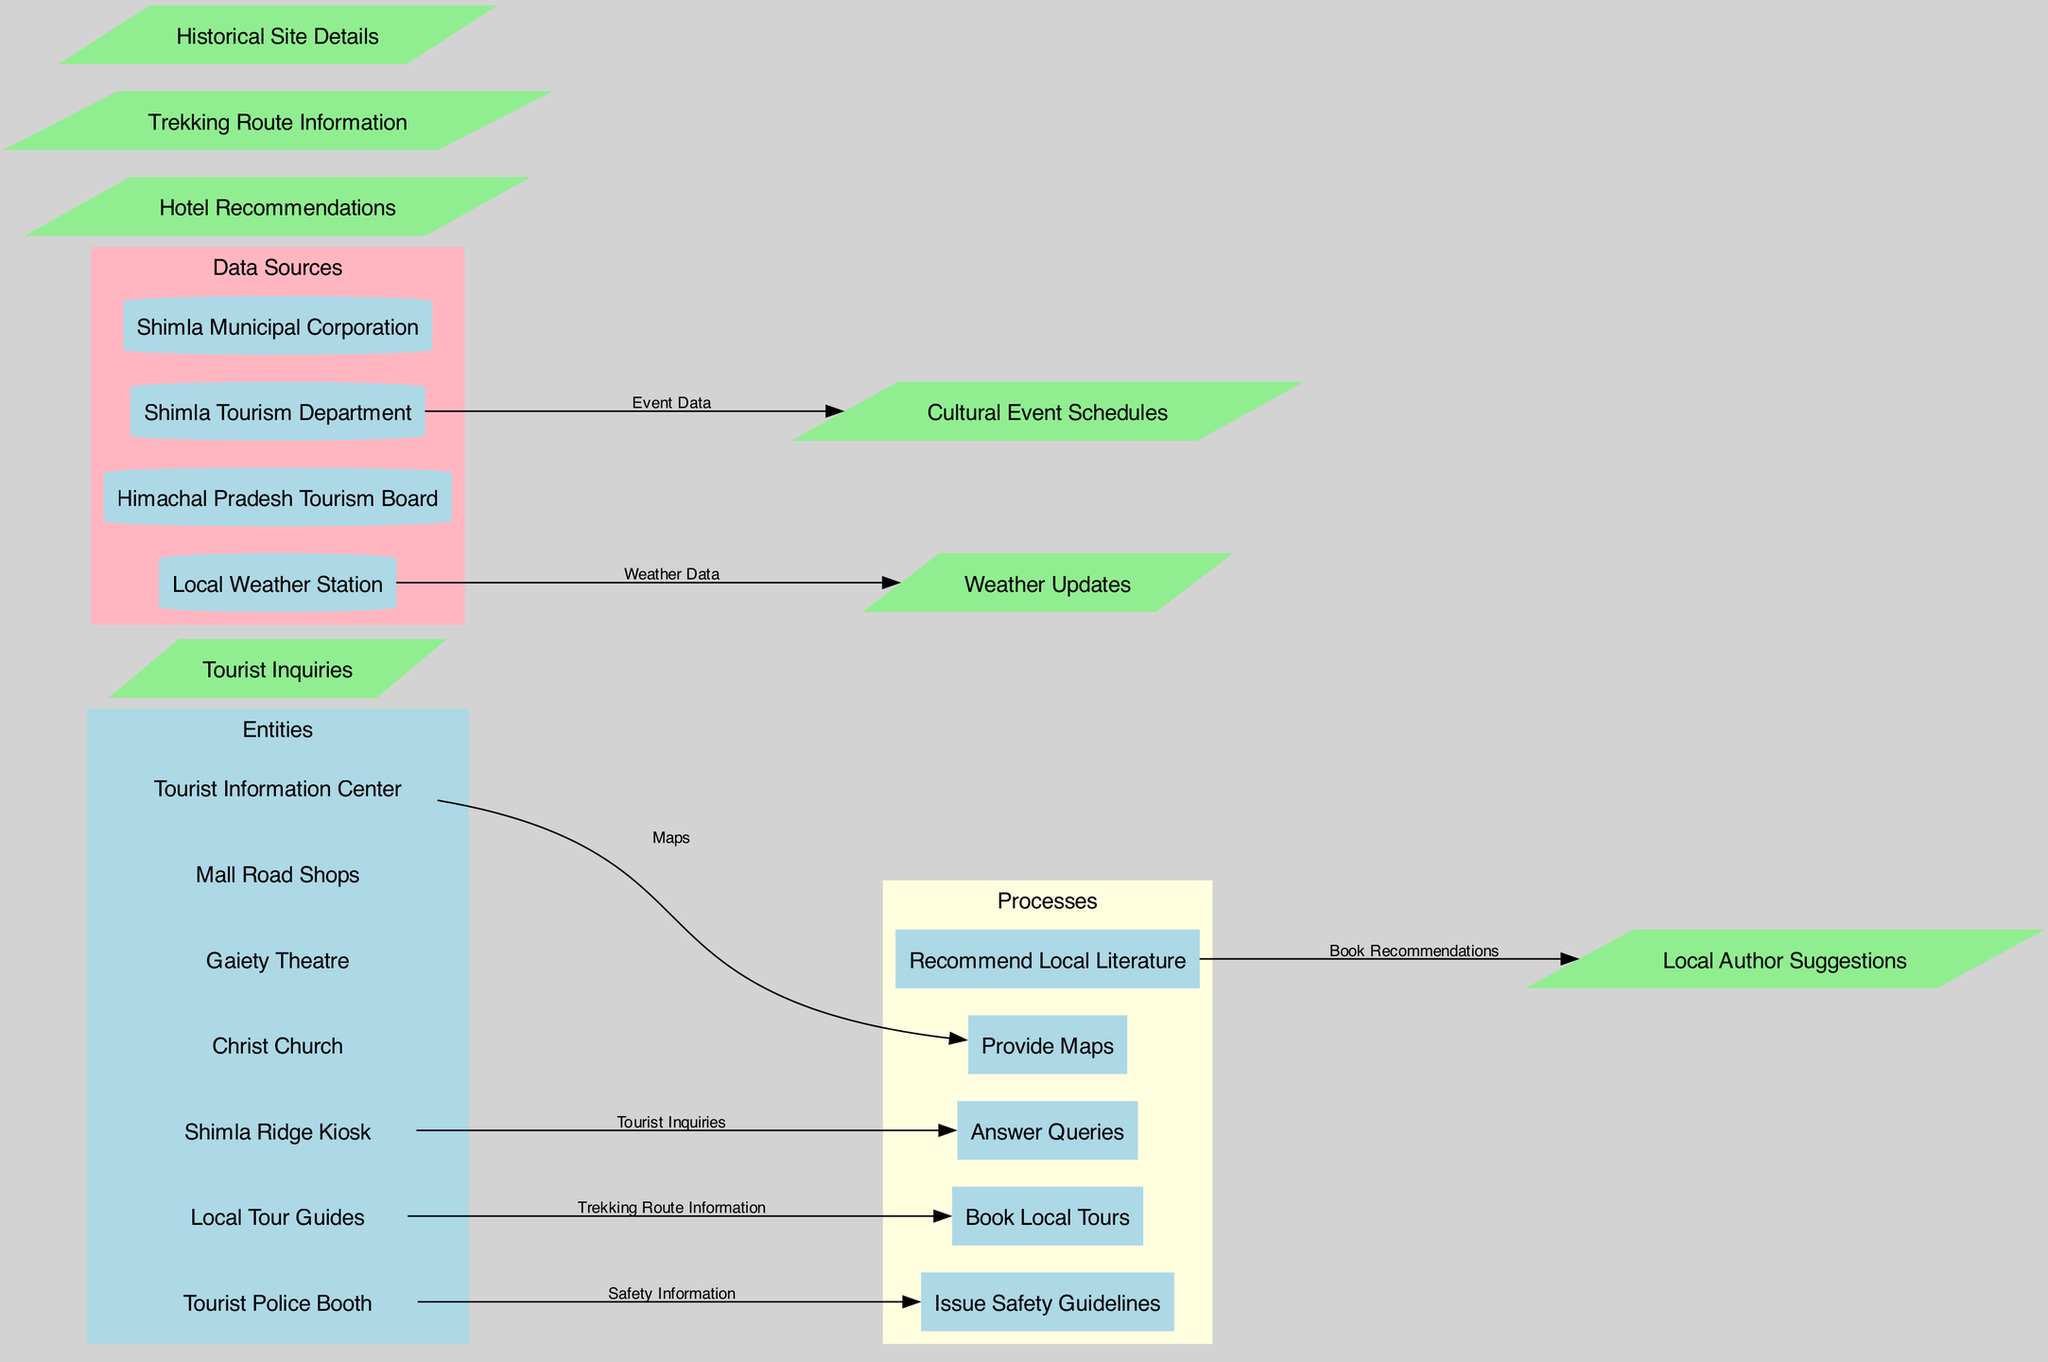What is the primary entity that provides maps to tourists? The diagram shows that the "Tourist Information Center" is connected to the process "Provide Maps," indicating that it is the entity responsible for this function.
Answer: Tourist Information Center How many processes are represented in the diagram? There are five distinct processes listed in the diagram: "Provide Maps," "Answer Queries," "Book Local Tours," "Issue Safety Guidelines," and "Recommend Local Literature." Thus, the count is five.
Answer: 5 Which entity is associated with answering tourist inquiries? The edge connecting "Shimla Ridge Kiosk" to the process "Answer Queries" indicates that this entity is specifically responsible for handling tourist inquiries.
Answer: Shimla Ridge Kiosk What type of information is provided by the Local Tour Guides? The diagram shows that "Local Tour Guides" are connected to the process "Book Local Tours," which implies they provide information related to local tours.
Answer: Trekking Route Information Which data source offers weather updates? The "Local Weather Station" is the data source linked directly to "Weather Updates," indicating that it provides this specific information.
Answer: Local Weather Station What is the color of the processes in the diagram? The processes are represented with a light yellow background color in the diagram, distinguishing them from the other elements.
Answer: Light yellow How does the Tourist Police Booth contribute to the information flow? By connecting the "Tourist Police Booth" to the process "Issue Safety Guidelines," the diagram depicts its role in providing safety-related information to tourists.
Answer: Issue Safety Guidelines Which entity recommends local literature to tourists? The "Recommend Local Literature" process, connected to local author suggestions, indicates that the entity involved in this is directly associated with literary recommendations.
Answer: Recommend Local Literature What is the relationship between the Shimla Tourism Department and cultural events? The edge linking "Shimla Tourism Department" to the "Cultural Event Schedules" indicates that this data source provides information about cultural events happening in the area.
Answer: Cultural Event Schedules 